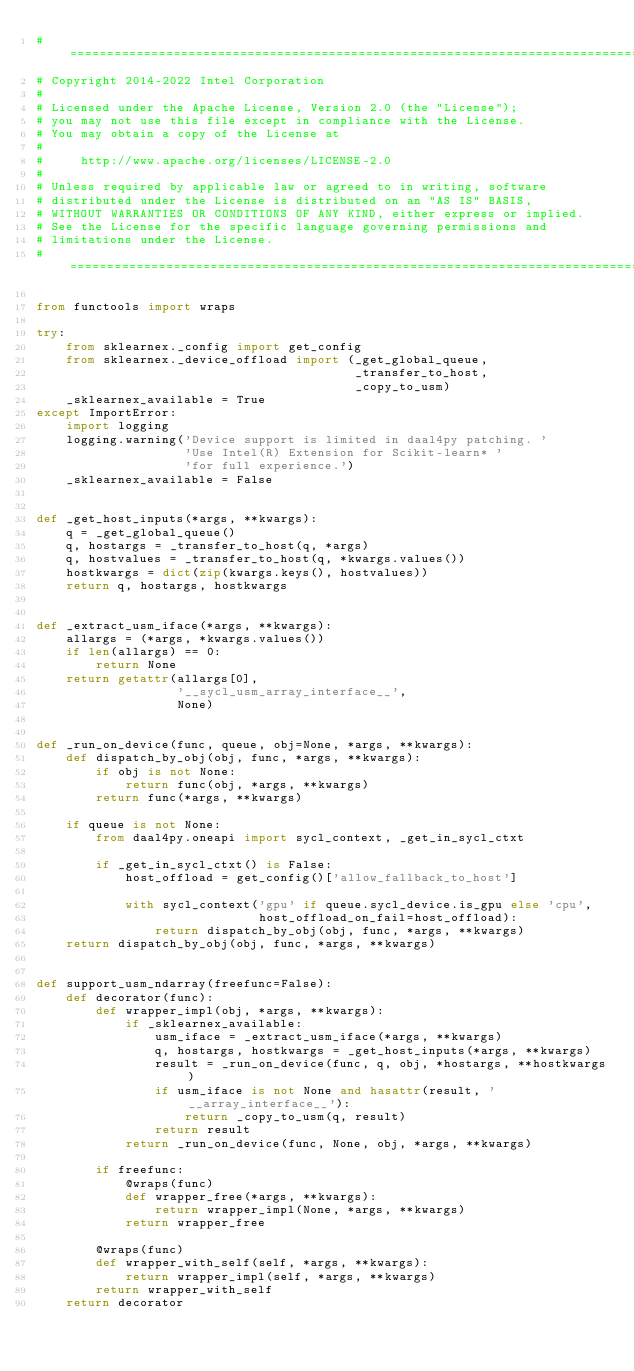<code> <loc_0><loc_0><loc_500><loc_500><_Python_>#===============================================================================
# Copyright 2014-2022 Intel Corporation
#
# Licensed under the Apache License, Version 2.0 (the "License");
# you may not use this file except in compliance with the License.
# You may obtain a copy of the License at
#
#     http://www.apache.org/licenses/LICENSE-2.0
#
# Unless required by applicable law or agreed to in writing, software
# distributed under the License is distributed on an "AS IS" BASIS,
# WITHOUT WARRANTIES OR CONDITIONS OF ANY KIND, either express or implied.
# See the License for the specific language governing permissions and
# limitations under the License.
#===============================================================================

from functools import wraps

try:
    from sklearnex._config import get_config
    from sklearnex._device_offload import (_get_global_queue,
                                           _transfer_to_host,
                                           _copy_to_usm)
    _sklearnex_available = True
except ImportError:
    import logging
    logging.warning('Device support is limited in daal4py patching. '
                    'Use Intel(R) Extension for Scikit-learn* '
                    'for full experience.')
    _sklearnex_available = False


def _get_host_inputs(*args, **kwargs):
    q = _get_global_queue()
    q, hostargs = _transfer_to_host(q, *args)
    q, hostvalues = _transfer_to_host(q, *kwargs.values())
    hostkwargs = dict(zip(kwargs.keys(), hostvalues))
    return q, hostargs, hostkwargs


def _extract_usm_iface(*args, **kwargs):
    allargs = (*args, *kwargs.values())
    if len(allargs) == 0:
        return None
    return getattr(allargs[0],
                   '__sycl_usm_array_interface__',
                   None)


def _run_on_device(func, queue, obj=None, *args, **kwargs):
    def dispatch_by_obj(obj, func, *args, **kwargs):
        if obj is not None:
            return func(obj, *args, **kwargs)
        return func(*args, **kwargs)

    if queue is not None:
        from daal4py.oneapi import sycl_context, _get_in_sycl_ctxt

        if _get_in_sycl_ctxt() is False:
            host_offload = get_config()['allow_fallback_to_host']

            with sycl_context('gpu' if queue.sycl_device.is_gpu else 'cpu',
                              host_offload_on_fail=host_offload):
                return dispatch_by_obj(obj, func, *args, **kwargs)
    return dispatch_by_obj(obj, func, *args, **kwargs)


def support_usm_ndarray(freefunc=False):
    def decorator(func):
        def wrapper_impl(obj, *args, **kwargs):
            if _sklearnex_available:
                usm_iface = _extract_usm_iface(*args, **kwargs)
                q, hostargs, hostkwargs = _get_host_inputs(*args, **kwargs)
                result = _run_on_device(func, q, obj, *hostargs, **hostkwargs)
                if usm_iface is not None and hasattr(result, '__array_interface__'):
                    return _copy_to_usm(q, result)
                return result
            return _run_on_device(func, None, obj, *args, **kwargs)

        if freefunc:
            @wraps(func)
            def wrapper_free(*args, **kwargs):
                return wrapper_impl(None, *args, **kwargs)
            return wrapper_free

        @wraps(func)
        def wrapper_with_self(self, *args, **kwargs):
            return wrapper_impl(self, *args, **kwargs)
        return wrapper_with_self
    return decorator
</code> 